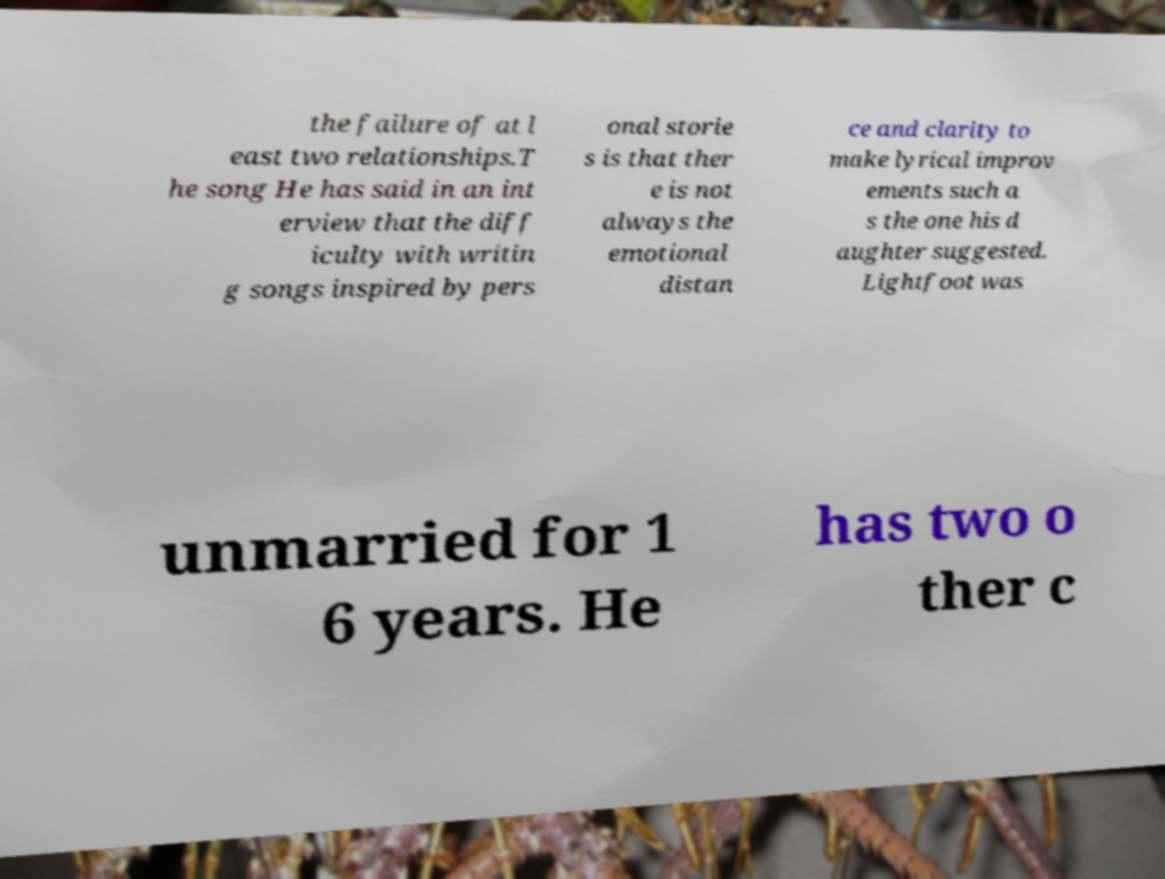Can you read and provide the text displayed in the image?This photo seems to have some interesting text. Can you extract and type it out for me? the failure of at l east two relationships.T he song He has said in an int erview that the diff iculty with writin g songs inspired by pers onal storie s is that ther e is not always the emotional distan ce and clarity to make lyrical improv ements such a s the one his d aughter suggested. Lightfoot was unmarried for 1 6 years. He has two o ther c 